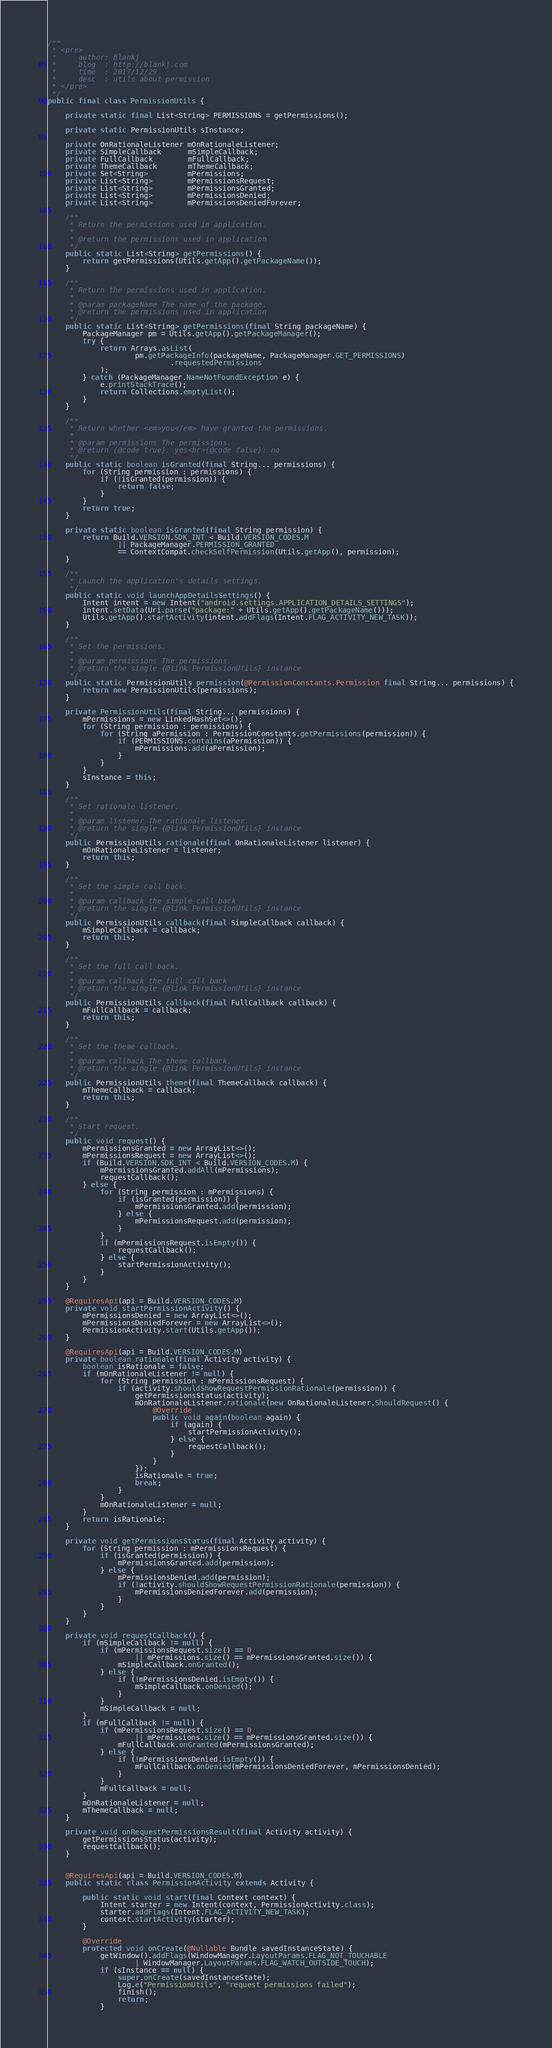Convert code to text. <code><loc_0><loc_0><loc_500><loc_500><_Java_>
/**
 * <pre>
 *     author: Blankj
 *     blog  : http://blankj.com
 *     time  : 2017/12/29
 *     desc  : utils about permission
 * </pre>
 */
public final class PermissionUtils {

    private static final List<String> PERMISSIONS = getPermissions();

    private static PermissionUtils sInstance;

    private OnRationaleListener mOnRationaleListener;
    private SimpleCallback      mSimpleCallback;
    private FullCallback        mFullCallback;
    private ThemeCallback       mThemeCallback;
    private Set<String>         mPermissions;
    private List<String>        mPermissionsRequest;
    private List<String>        mPermissionsGranted;
    private List<String>        mPermissionsDenied;
    private List<String>        mPermissionsDeniedForever;

    /**
     * Return the permissions used in application.
     *
     * @return the permissions used in application
     */
    public static List<String> getPermissions() {
        return getPermissions(Utils.getApp().getPackageName());
    }

    /**
     * Return the permissions used in application.
     *
     * @param packageName The name of the package.
     * @return the permissions used in application
     */
    public static List<String> getPermissions(final String packageName) {
        PackageManager pm = Utils.getApp().getPackageManager();
        try {
            return Arrays.asList(
                    pm.getPackageInfo(packageName, PackageManager.GET_PERMISSIONS)
                            .requestedPermissions
            );
        } catch (PackageManager.NameNotFoundException e) {
            e.printStackTrace();
            return Collections.emptyList();
        }
    }

    /**
     * Return whether <em>you</em> have granted the permissions.
     *
     * @param permissions The permissions.
     * @return {@code true}: yes<br>{@code false}: no
     */
    public static boolean isGranted(final String... permissions) {
        for (String permission : permissions) {
            if (!isGranted(permission)) {
                return false;
            }
        }
        return true;
    }

    private static boolean isGranted(final String permission) {
        return Build.VERSION.SDK_INT < Build.VERSION_CODES.M
                || PackageManager.PERMISSION_GRANTED
                == ContextCompat.checkSelfPermission(Utils.getApp(), permission);
    }

    /**
     * Launch the application's details settings.
     */
    public static void launchAppDetailsSettings() {
        Intent intent = new Intent("android.settings.APPLICATION_DETAILS_SETTINGS");
        intent.setData(Uri.parse("package:" + Utils.getApp().getPackageName()));
        Utils.getApp().startActivity(intent.addFlags(Intent.FLAG_ACTIVITY_NEW_TASK));
    }

    /**
     * Set the permissions.
     *
     * @param permissions The permissions.
     * @return the single {@link PermissionUtils} instance
     */
    public static PermissionUtils permission(@PermissionConstants.Permission final String... permissions) {
        return new PermissionUtils(permissions);
    }

    private PermissionUtils(final String... permissions) {
        mPermissions = new LinkedHashSet<>();
        for (String permission : permissions) {
            for (String aPermission : PermissionConstants.getPermissions(permission)) {
                if (PERMISSIONS.contains(aPermission)) {
                    mPermissions.add(aPermission);
                }
            }
        }
        sInstance = this;
    }

    /**
     * Set rationale listener.
     *
     * @param listener The rationale listener.
     * @return the single {@link PermissionUtils} instance
     */
    public PermissionUtils rationale(final OnRationaleListener listener) {
        mOnRationaleListener = listener;
        return this;
    }

    /**
     * Set the simple call back.
     *
     * @param callback the simple call back
     * @return the single {@link PermissionUtils} instance
     */
    public PermissionUtils callback(final SimpleCallback callback) {
        mSimpleCallback = callback;
        return this;
    }

    /**
     * Set the full call back.
     *
     * @param callback the full call back
     * @return the single {@link PermissionUtils} instance
     */
    public PermissionUtils callback(final FullCallback callback) {
        mFullCallback = callback;
        return this;
    }

    /**
     * Set the theme callback.
     *
     * @param callback The theme callback.
     * @return the single {@link PermissionUtils} instance
     */
    public PermissionUtils theme(final ThemeCallback callback) {
        mThemeCallback = callback;
        return this;
    }

    /**
     * Start request.
     */
    public void request() {
        mPermissionsGranted = new ArrayList<>();
        mPermissionsRequest = new ArrayList<>();
        if (Build.VERSION.SDK_INT < Build.VERSION_CODES.M) {
            mPermissionsGranted.addAll(mPermissions);
            requestCallback();
        } else {
            for (String permission : mPermissions) {
                if (isGranted(permission)) {
                    mPermissionsGranted.add(permission);
                } else {
                    mPermissionsRequest.add(permission);
                }
            }
            if (mPermissionsRequest.isEmpty()) {
                requestCallback();
            } else {
                startPermissionActivity();
            }
        }
    }

    @RequiresApi(api = Build.VERSION_CODES.M)
    private void startPermissionActivity() {
        mPermissionsDenied = new ArrayList<>();
        mPermissionsDeniedForever = new ArrayList<>();
        PermissionActivity.start(Utils.getApp());
    }

    @RequiresApi(api = Build.VERSION_CODES.M)
    private boolean rationale(final Activity activity) {
        boolean isRationale = false;
        if (mOnRationaleListener != null) {
            for (String permission : mPermissionsRequest) {
                if (activity.shouldShowRequestPermissionRationale(permission)) {
                    getPermissionsStatus(activity);
                    mOnRationaleListener.rationale(new OnRationaleListener.ShouldRequest() {
                        @Override
                        public void again(boolean again) {
                            if (again) {
                                startPermissionActivity();
                            } else {
                                requestCallback();
                            }
                        }
                    });
                    isRationale = true;
                    break;
                }
            }
            mOnRationaleListener = null;
        }
        return isRationale;
    }

    private void getPermissionsStatus(final Activity activity) {
        for (String permission : mPermissionsRequest) {
            if (isGranted(permission)) {
                mPermissionsGranted.add(permission);
            } else {
                mPermissionsDenied.add(permission);
                if (!activity.shouldShowRequestPermissionRationale(permission)) {
                    mPermissionsDeniedForever.add(permission);
                }
            }
        }
    }

    private void requestCallback() {
        if (mSimpleCallback != null) {
            if (mPermissionsRequest.size() == 0
                    || mPermissions.size() == mPermissionsGranted.size()) {
                mSimpleCallback.onGranted();
            } else {
                if (!mPermissionsDenied.isEmpty()) {
                    mSimpleCallback.onDenied();
                }
            }
            mSimpleCallback = null;
        }
        if (mFullCallback != null) {
            if (mPermissionsRequest.size() == 0
                    || mPermissions.size() == mPermissionsGranted.size()) {
                mFullCallback.onGranted(mPermissionsGranted);
            } else {
                if (!mPermissionsDenied.isEmpty()) {
                    mFullCallback.onDenied(mPermissionsDeniedForever, mPermissionsDenied);
                }
            }
            mFullCallback = null;
        }
        mOnRationaleListener = null;
        mThemeCallback = null;
    }

    private void onRequestPermissionsResult(final Activity activity) {
        getPermissionsStatus(activity);
        requestCallback();
    }


    @RequiresApi(api = Build.VERSION_CODES.M)
    public static class PermissionActivity extends Activity {

        public static void start(final Context context) {
            Intent starter = new Intent(context, PermissionActivity.class);
            starter.addFlags(Intent.FLAG_ACTIVITY_NEW_TASK);
            context.startActivity(starter);
        }

        @Override
        protected void onCreate(@Nullable Bundle savedInstanceState) {
            getWindow().addFlags(WindowManager.LayoutParams.FLAG_NOT_TOUCHABLE
                    | WindowManager.LayoutParams.FLAG_WATCH_OUTSIDE_TOUCH);
            if (sInstance == null) {
                super.onCreate(savedInstanceState);
                Log.e("PermissionUtils", "request permissions failed");
                finish();
                return;
            }</code> 